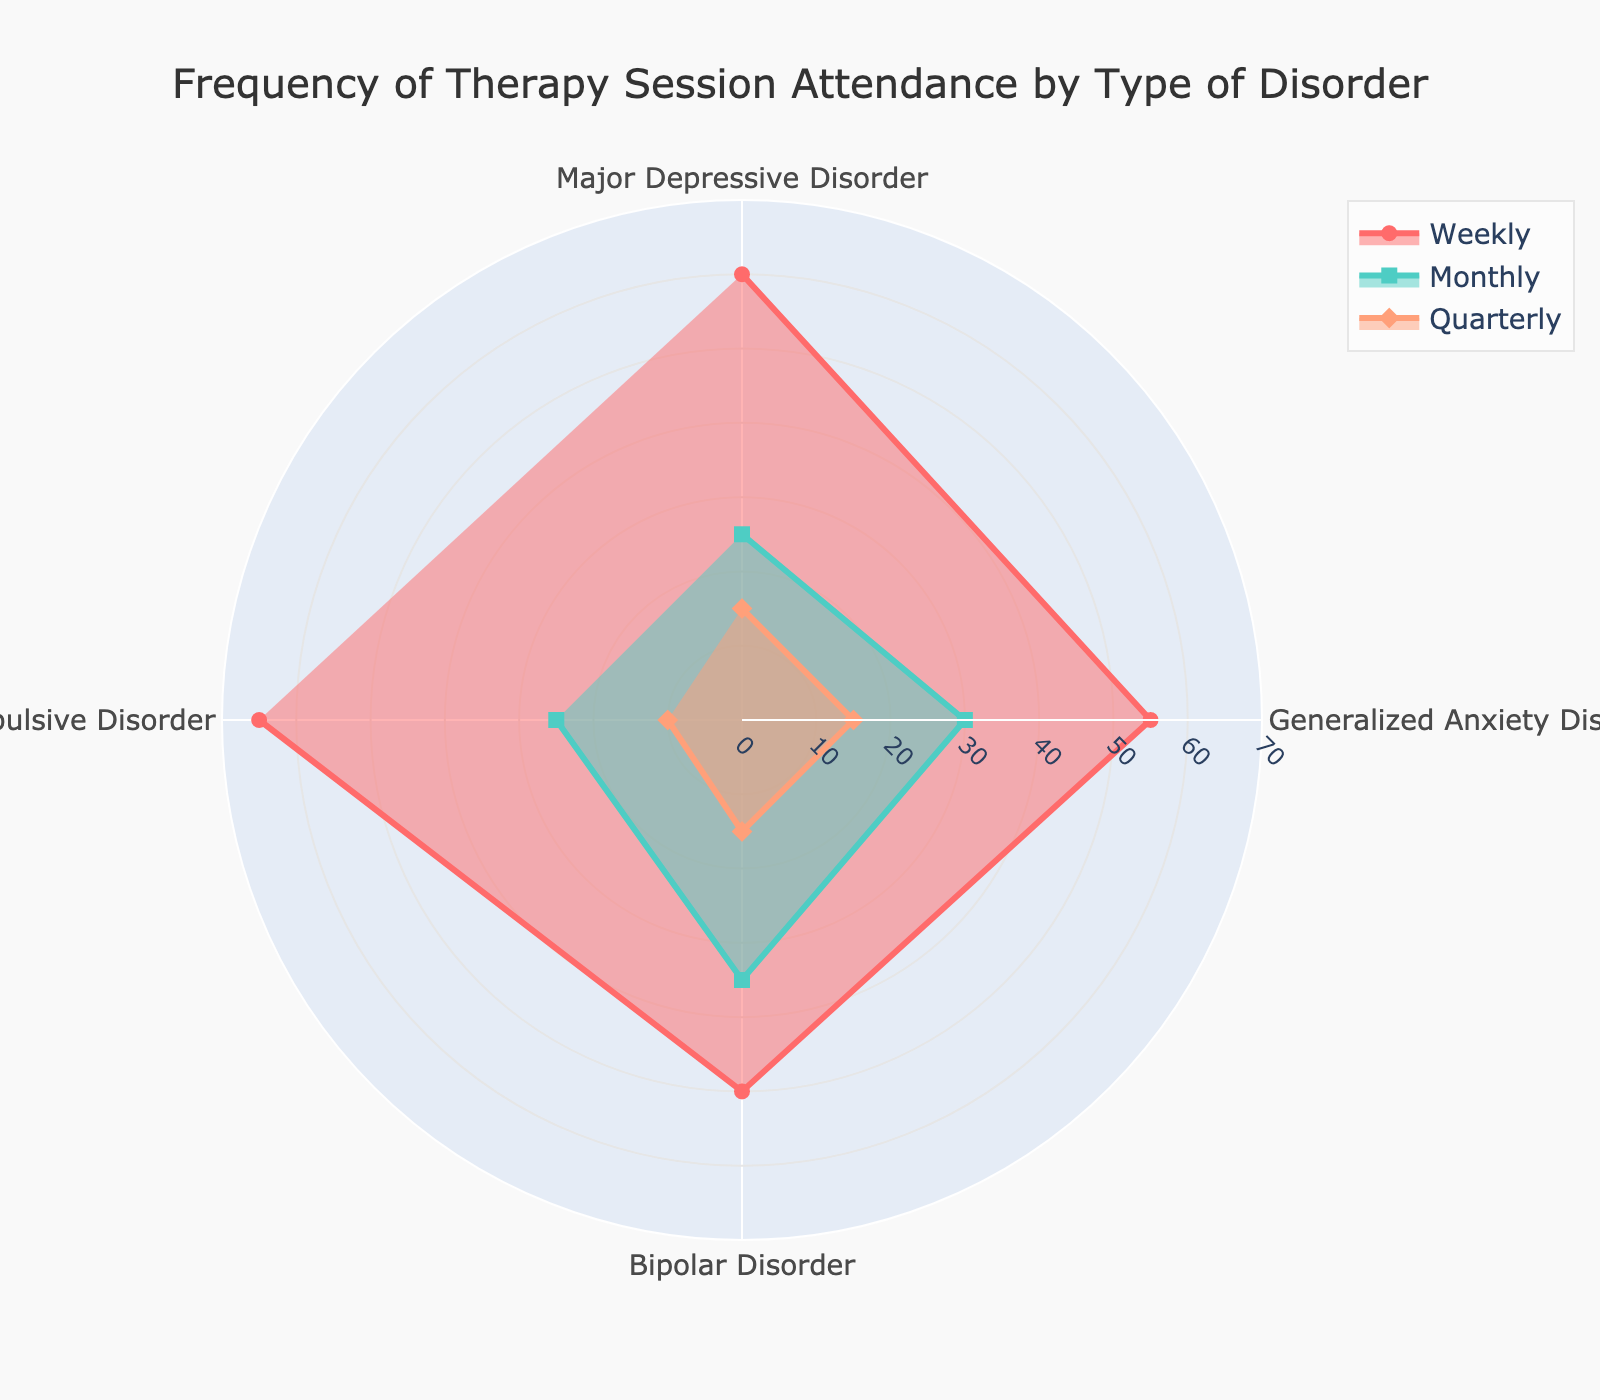How many disorders are displayed in the radar chart? The radar chart displays frequency attendance data for each type of disorder. By counting the number of unique disorders, we can determine that there are four disorders shown.
Answer: Four Which disorder has the highest percentage of weekly therapy session attendance? By observing the radar chart, we can see the "Weekly" data points. The one with the highest value relative to the others represents the highest percentage. For "Weekly," Obsessive-Compulsive Disorder has the highest percentage at 65%.
Answer: Obsessive-Compulsive Disorder What is the sum of the monthly attendance percentages for all disorders? The monthly attendance percentages are given for each disorder. Sum them up: 25 (MDD) + 30 (GAD) + 35 (Bipolar) + 25 (OCD) = 115.
Answer: 115 Between Generalized Anxiety Disorder and Bipolar Disorder, which has a higher quarterly session attendance percentage? Compare the quarterly attendance percentages for both disorders. Generalized Anxiety Disorder has 15%, while Bipolar Disorder also has 15%, so they are equal.
Answer: Equal What is the difference in weekly session attendance between Major Depressive Disorder and Bipolar Disorder? Subtract the percentage of Bipolar Disorder (50%) from Major Depressive Disorder (60%): 60 - 50 = 10.
Answer: 10 How does the quarterly session attendance for Obsessive-Compulsive Disorder compare to the other disorders? By looking at the "Quarterly" data points in the radar chart, Obsessive-Compulsive Disorder has the lowest quarterly session attendance at 10%. All other disorders have 15%. This means OCD's quarterly attendance is lower than the others.
Answer: Lower Which type of therapy session attendance (Weekly, Monthly, Quarterly) shows the smallest variation across the disorders? To determine this, we analyze the range in percentages across all disorders for each session type. Weekly varies from 50% to 65%, Monthly from 25% to 35%, and Quarterly from 10% to 15%. Quarterly has the smallest range (5%).
Answer: Quarterly For which disorder is the sum of weekly and monthly session attendance the highest? Calculate the sum of weekly and monthly percentages for each disorder: 
- MDD: 60 + 25 = 85
- GAD: 55 + 30 = 85
- Bipolar: 50 + 35 = 85
- OCD: 65 + 25 = 90.
OCD has the highest sum at 90.
Answer: Obsessive-Compulsive Disorder 